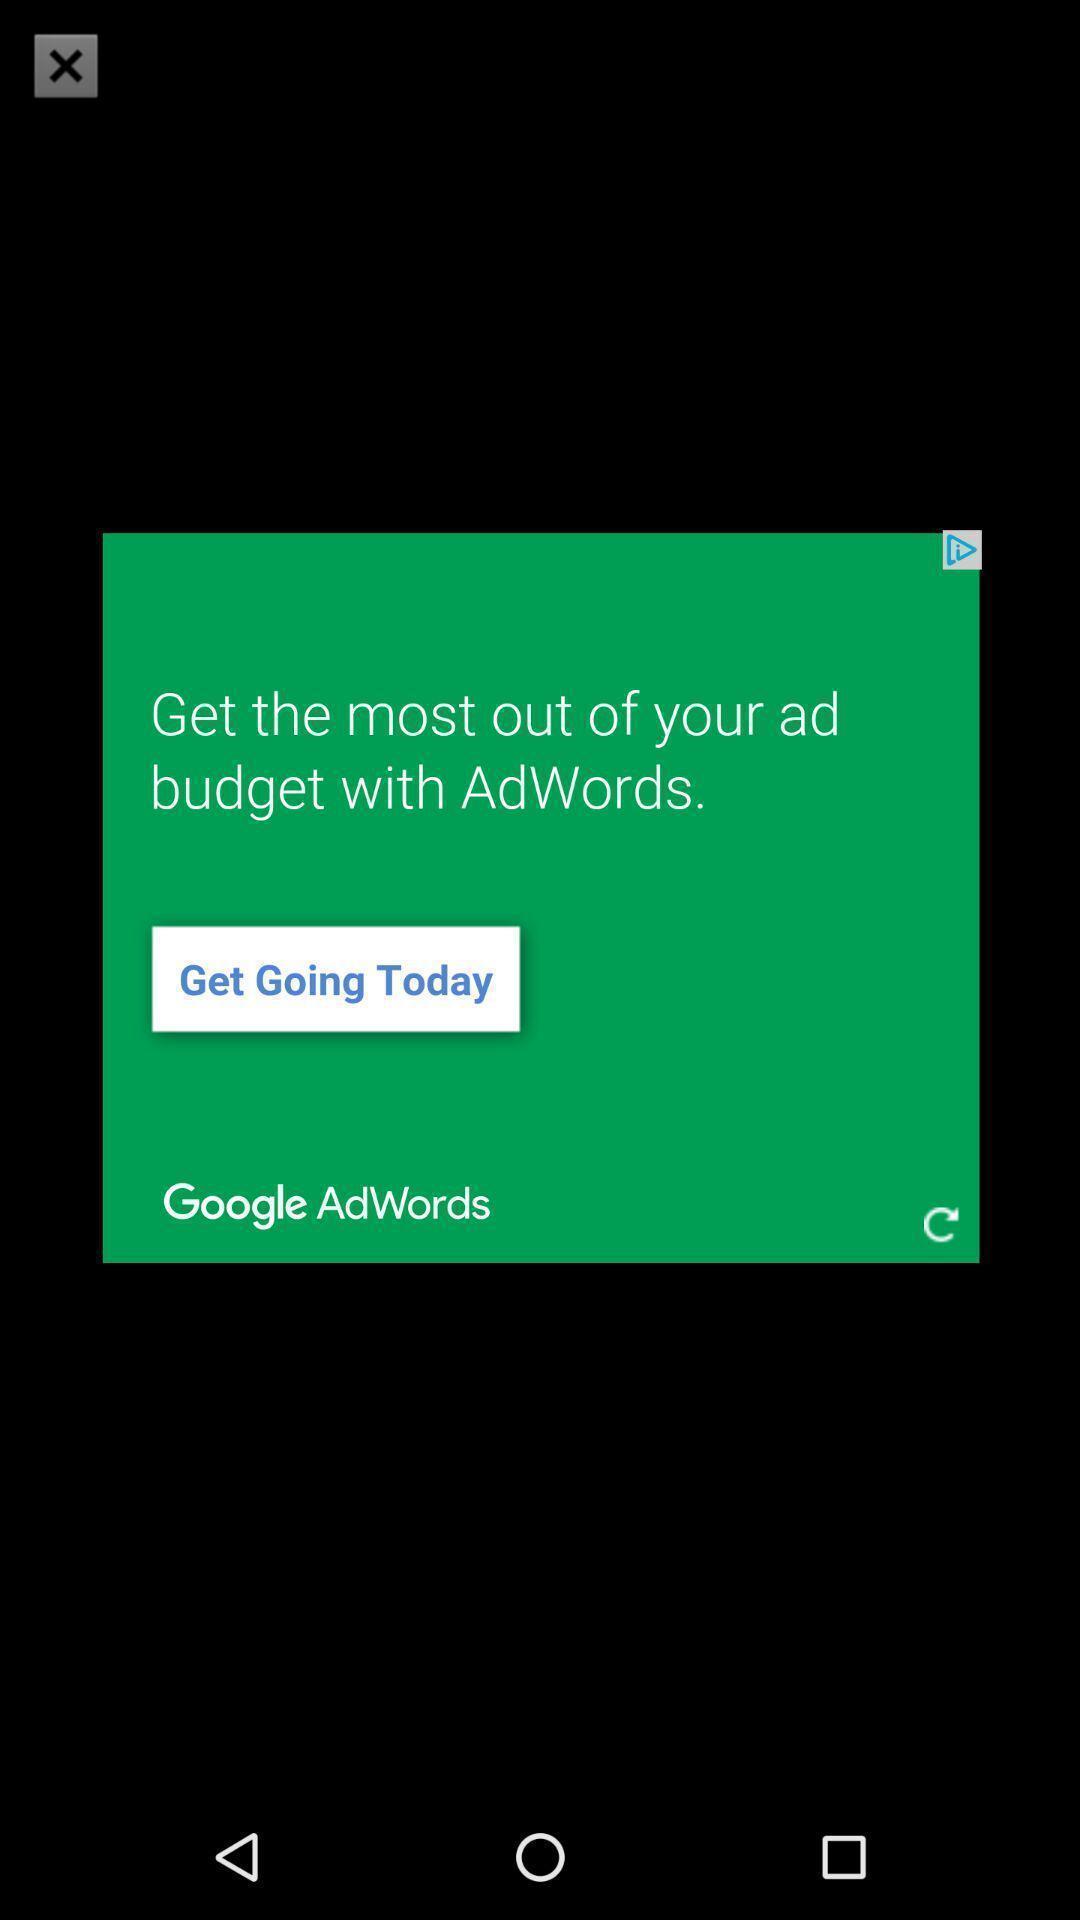Explain the elements present in this screenshot. Pop-up showing information about the advertising app. 